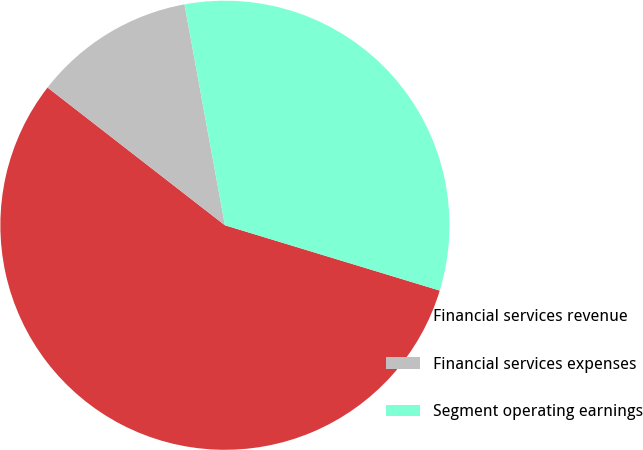<chart> <loc_0><loc_0><loc_500><loc_500><pie_chart><fcel>Financial services revenue<fcel>Financial services expenses<fcel>Segment operating earnings<nl><fcel>55.81%<fcel>11.61%<fcel>32.58%<nl></chart> 